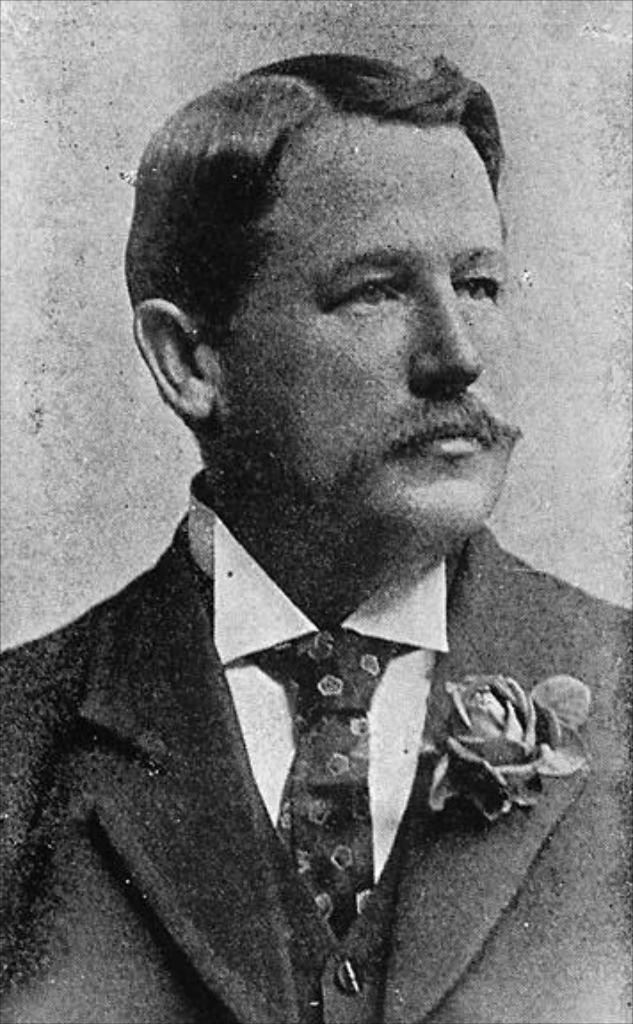What is the color scheme of the image? The image is black and white. Can you describe the person in the image? The person in the image is wearing a coat and tie. What is the setting of the image? There is a flower on the coast in the image. What type of cart can be seen in the image? There is no cart present in the image. Is there a bear visible in the image? There is no bear present in the image. 